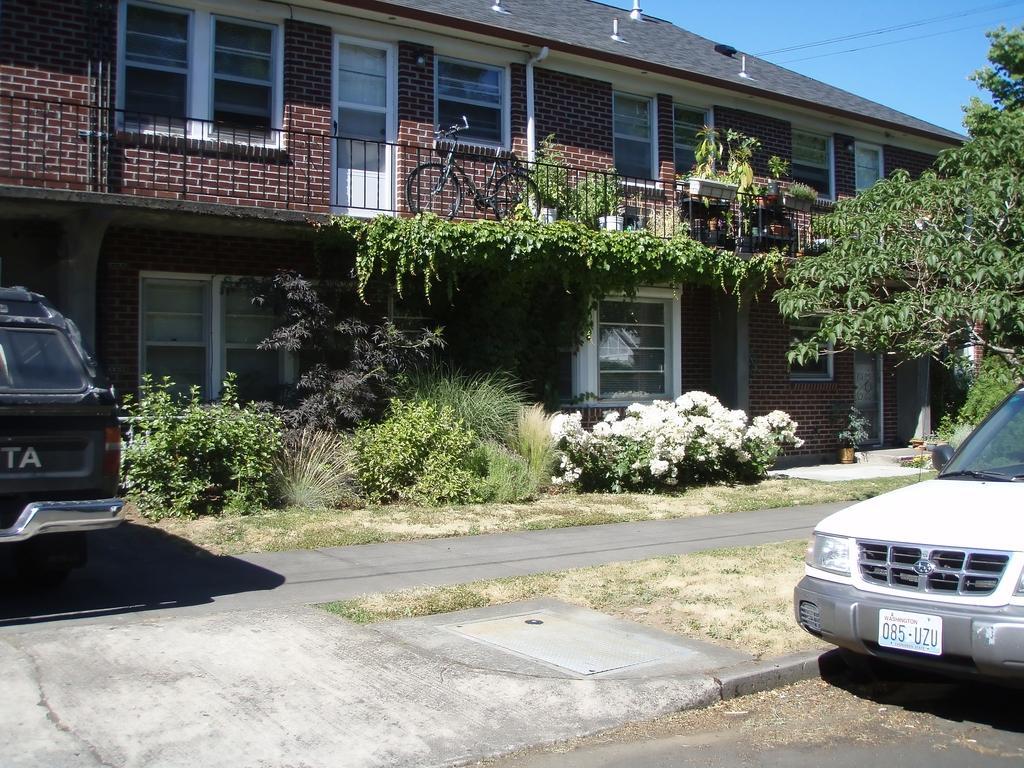Could you give a brief overview of what you see in this image? In this image there are houses and also i can see some plants flower pots, glass windows, railing, cycles. And on the right side and left side there are vehicles, at the bottom there is a walkway and grass. And at the top of the image there is sky and wires. 